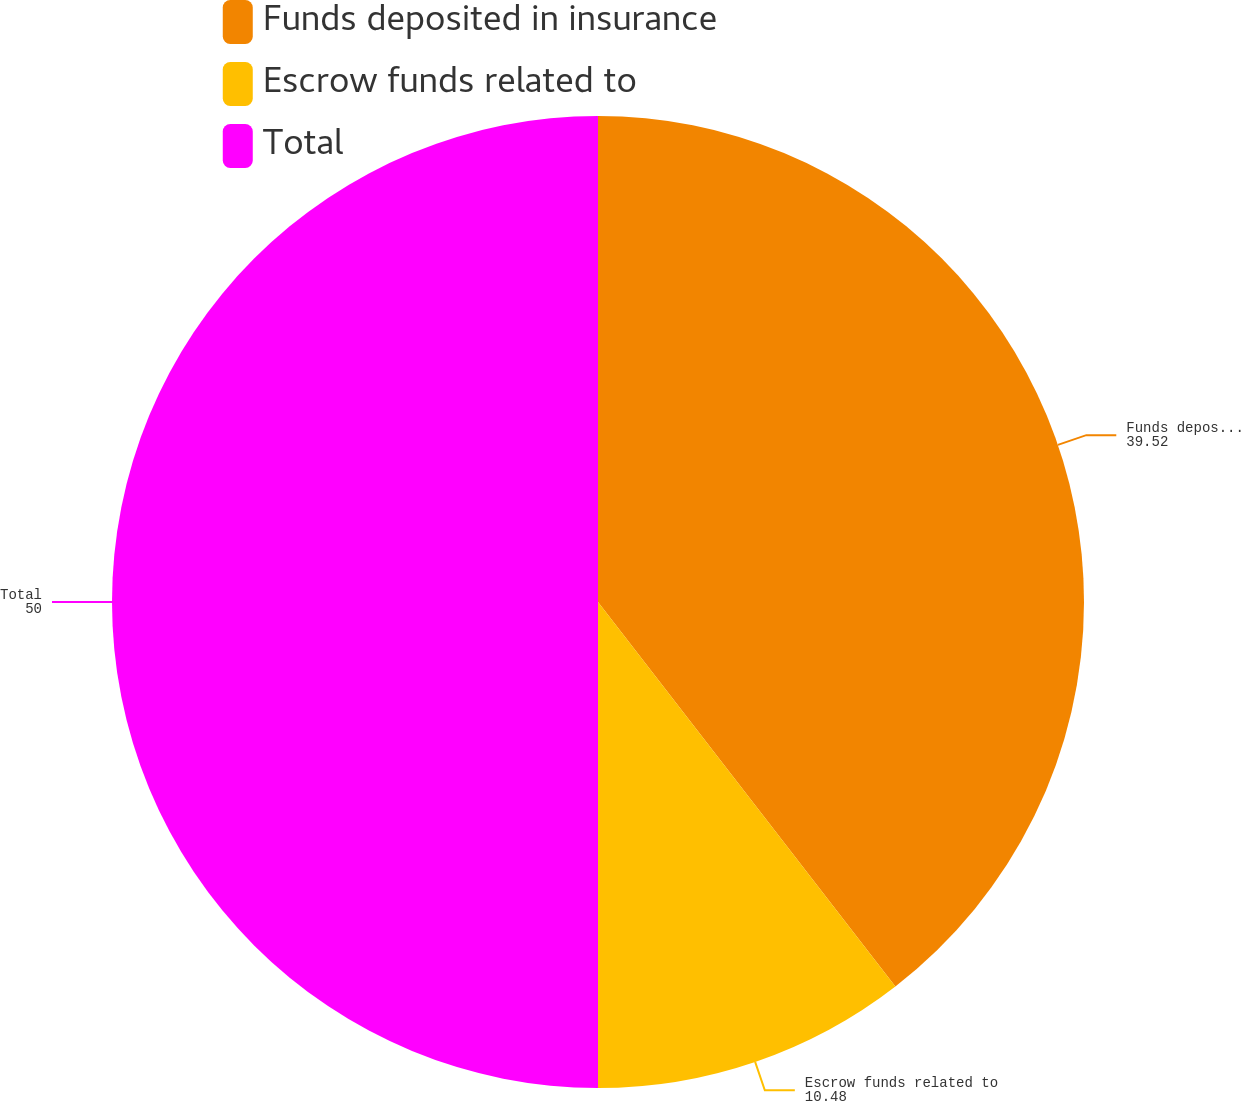Convert chart to OTSL. <chart><loc_0><loc_0><loc_500><loc_500><pie_chart><fcel>Funds deposited in insurance<fcel>Escrow funds related to<fcel>Total<nl><fcel>39.52%<fcel>10.48%<fcel>50.0%<nl></chart> 